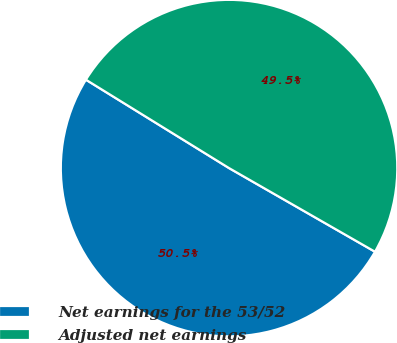Convert chart. <chart><loc_0><loc_0><loc_500><loc_500><pie_chart><fcel>Net earnings for the 53/52<fcel>Adjusted net earnings<nl><fcel>50.52%<fcel>49.48%<nl></chart> 